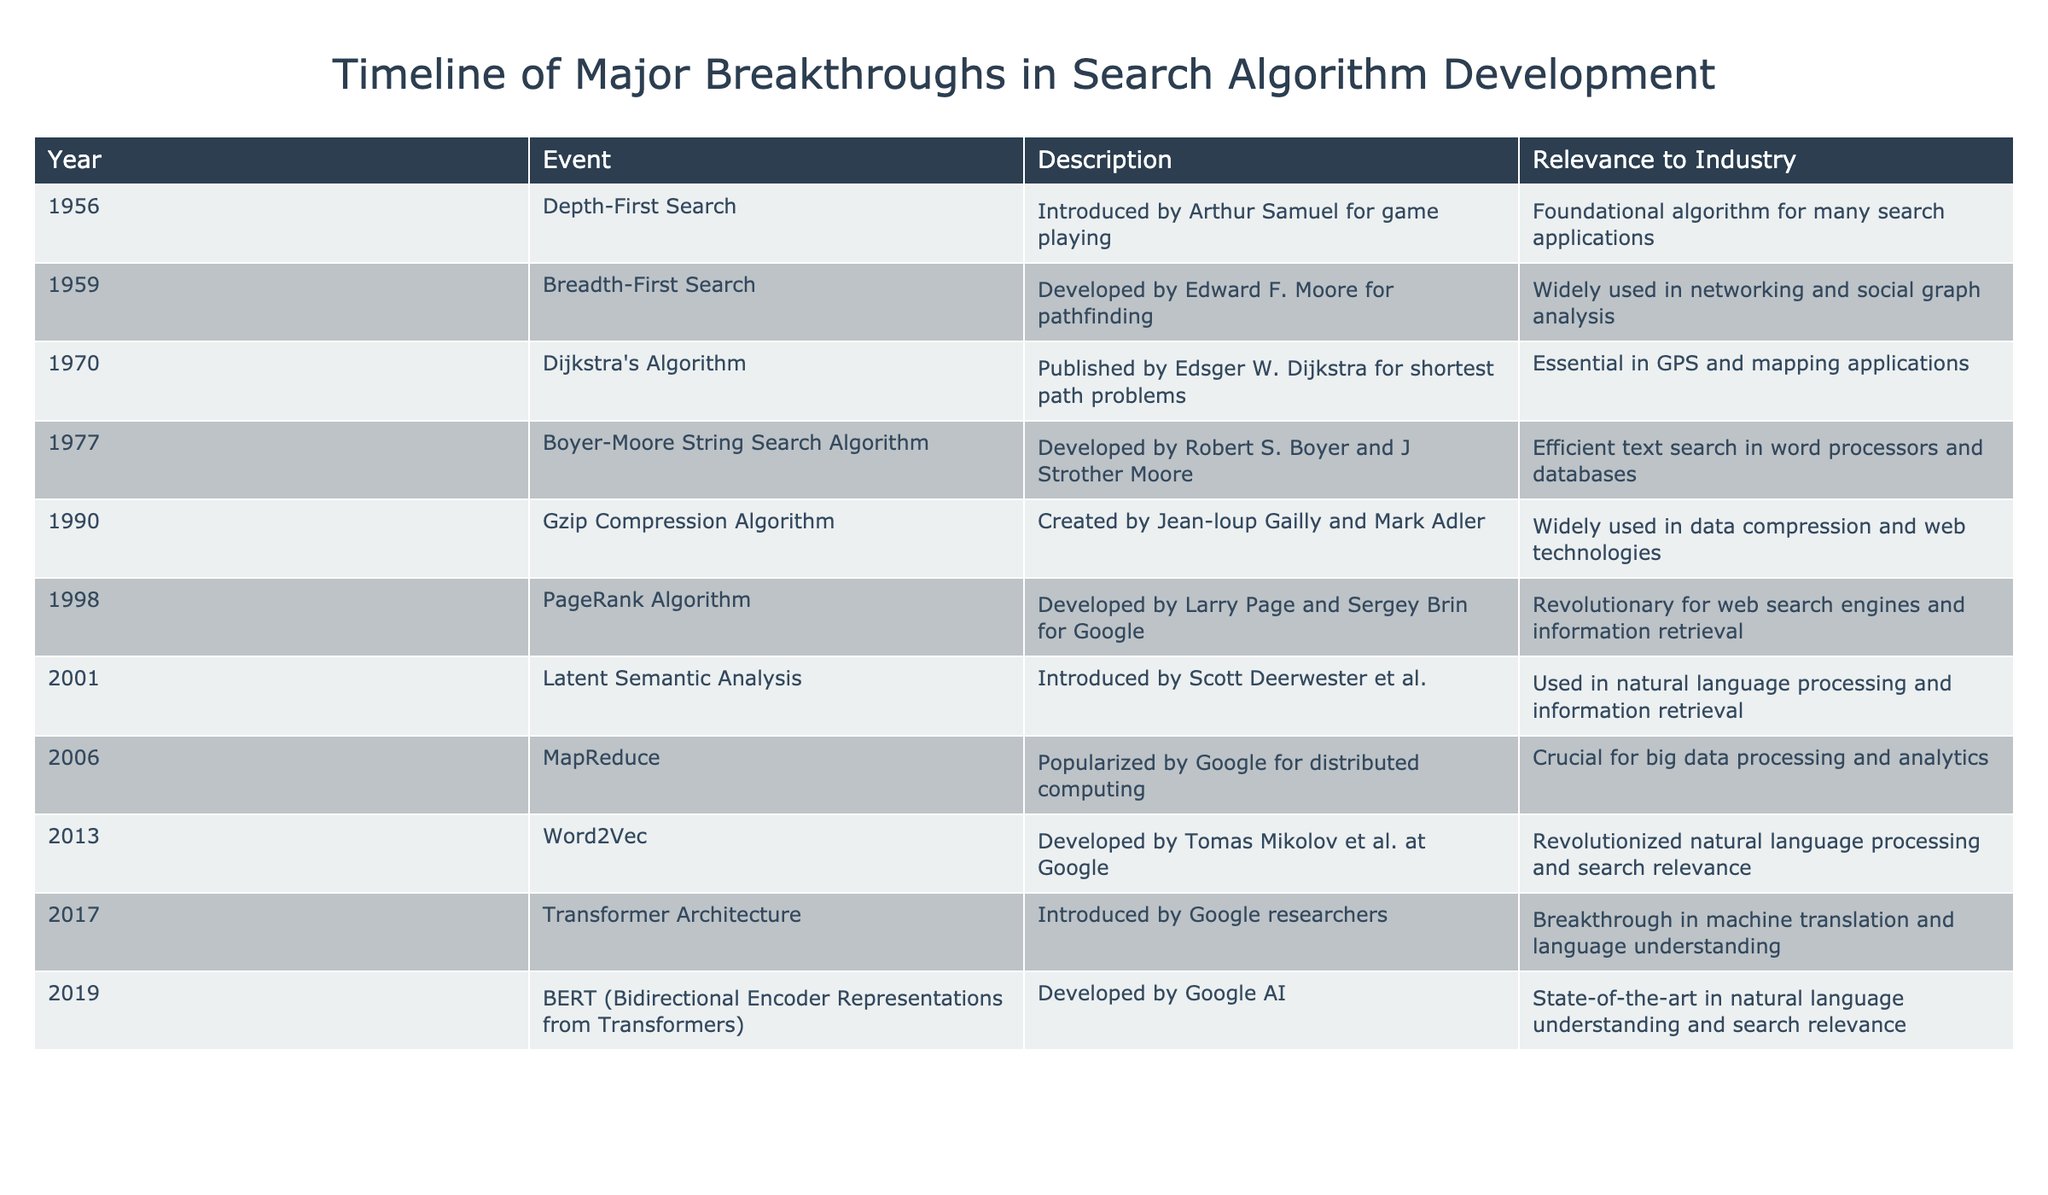What year was Dijkstra's Algorithm developed? The table indicates that Dijkstra's Algorithm was published in 1970, as listed under the "Year" column.
Answer: 1970 Which algorithm was introduced first, Depth-First Search or Breadth-First Search? The table shows that Depth-First Search was introduced in 1956 and Breadth-First Search was developed in 1959. Since 1956 is earlier than 1959, Depth-First Search is the first one.
Answer: Depth-First Search What is the relevance of PageRank to the industry? According to the description in the table, PageRank is revolutionary for web search engines and information retrieval, highlighting its significance in search industries.
Answer: Revolutionary for web search engines How many algorithms listed were introduced before 2000? Counting the years before 2000, we see Depth-First Search, Breadth-First Search, Dijkstra's Algorithm, Boyer-Moore, Gzip, and PageRank. That totals to six algorithms.
Answer: 6 Was the Boyer-Moore String Search Algorithm developed in the 1980s? The table states that the Boyer-Moore String Search Algorithm was developed in 1977. Since this is before the 1980s, the statement is false.
Answer: No Which search algorithm was significant for big data processing? The entry for MapReduce in the table points out that it was popularized by Google for distributed computing, making it crucial for big data processing and analytics.
Answer: MapReduce What breakthrough in search algorithms occurred in 2019, and what was its significance? The table shows that BERT was developed in 2019 and noted as state-of-the-art in natural language understanding and search relevance. This reveals its advanced capabilities in improving search algorithms.
Answer: BERT; state-of-the-art in natural language understanding If we look at the timeline, how many developments are there in the 2000s? There are four developments listed in the table for the years 2001 (Latent Semantic Analysis), 2006 (MapReduce), 2013 (Word2Vec), and 2019 (BERT), signifying four events in the specified decade.
Answer: 4 